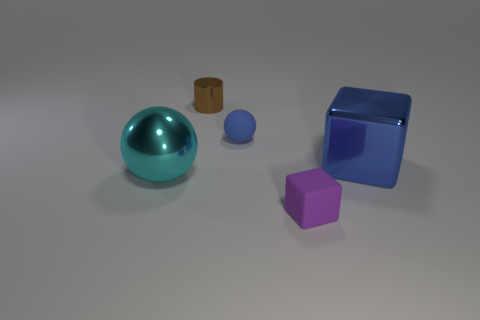Add 3 blue rubber things. How many objects exist? 8 Subtract all spheres. How many objects are left? 3 Subtract all gray balls. How many gray cylinders are left? 0 Subtract all matte things. Subtract all blue matte things. How many objects are left? 2 Add 2 small blue rubber spheres. How many small blue rubber spheres are left? 3 Add 1 small brown things. How many small brown things exist? 2 Subtract 0 gray blocks. How many objects are left? 5 Subtract 2 cubes. How many cubes are left? 0 Subtract all red spheres. Subtract all purple blocks. How many spheres are left? 2 